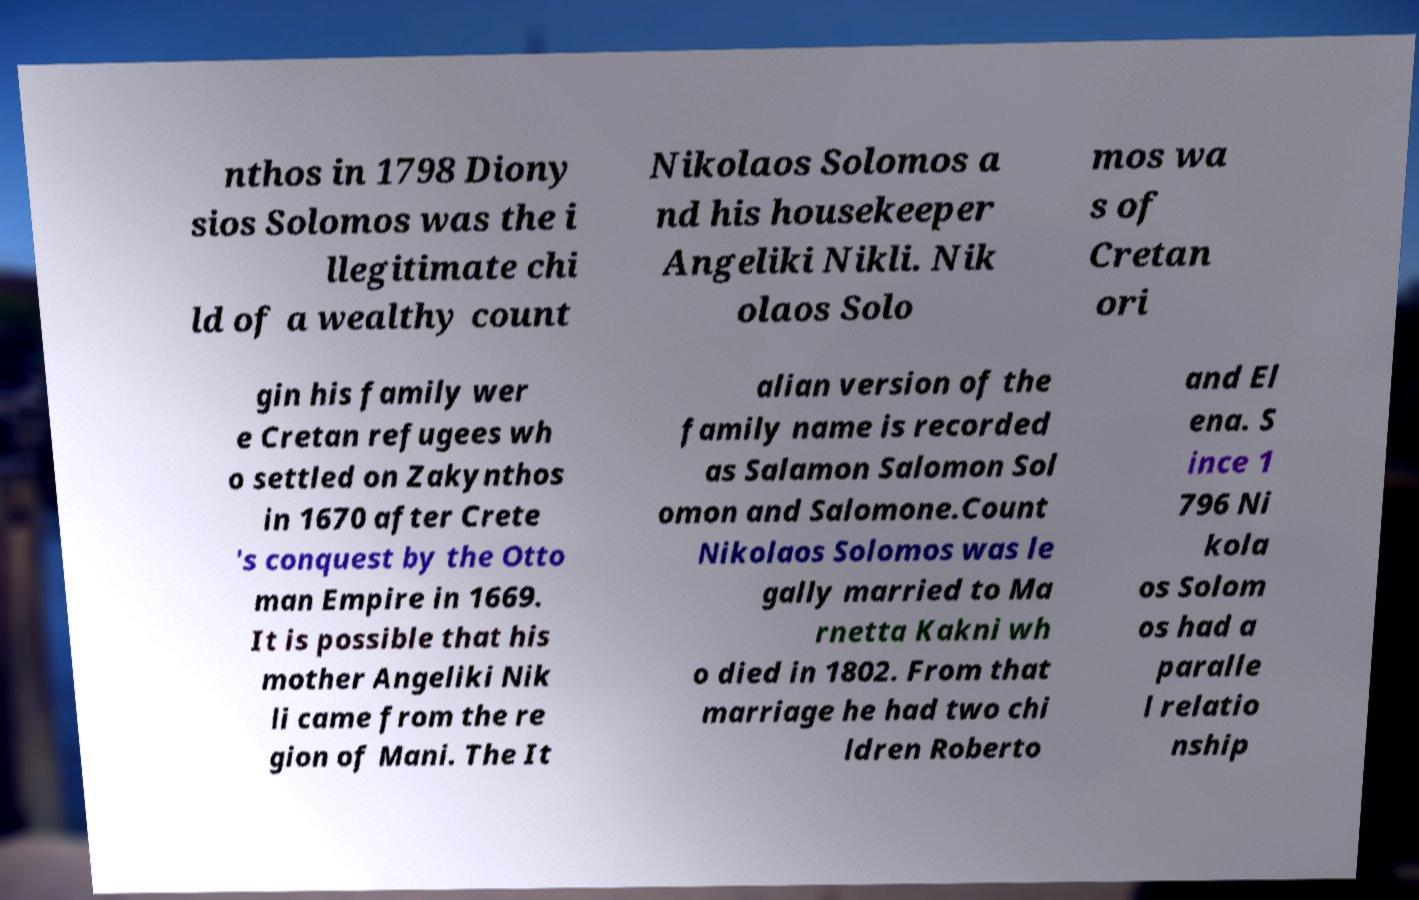What messages or text are displayed in this image? I need them in a readable, typed format. nthos in 1798 Diony sios Solomos was the i llegitimate chi ld of a wealthy count Nikolaos Solomos a nd his housekeeper Angeliki Nikli. Nik olaos Solo mos wa s of Cretan ori gin his family wer e Cretan refugees wh o settled on Zakynthos in 1670 after Crete 's conquest by the Otto man Empire in 1669. It is possible that his mother Angeliki Nik li came from the re gion of Mani. The It alian version of the family name is recorded as Salamon Salomon Sol omon and Salomone.Count Nikolaos Solomos was le gally married to Ma rnetta Kakni wh o died in 1802. From that marriage he had two chi ldren Roberto and El ena. S ince 1 796 Ni kola os Solom os had a paralle l relatio nship 